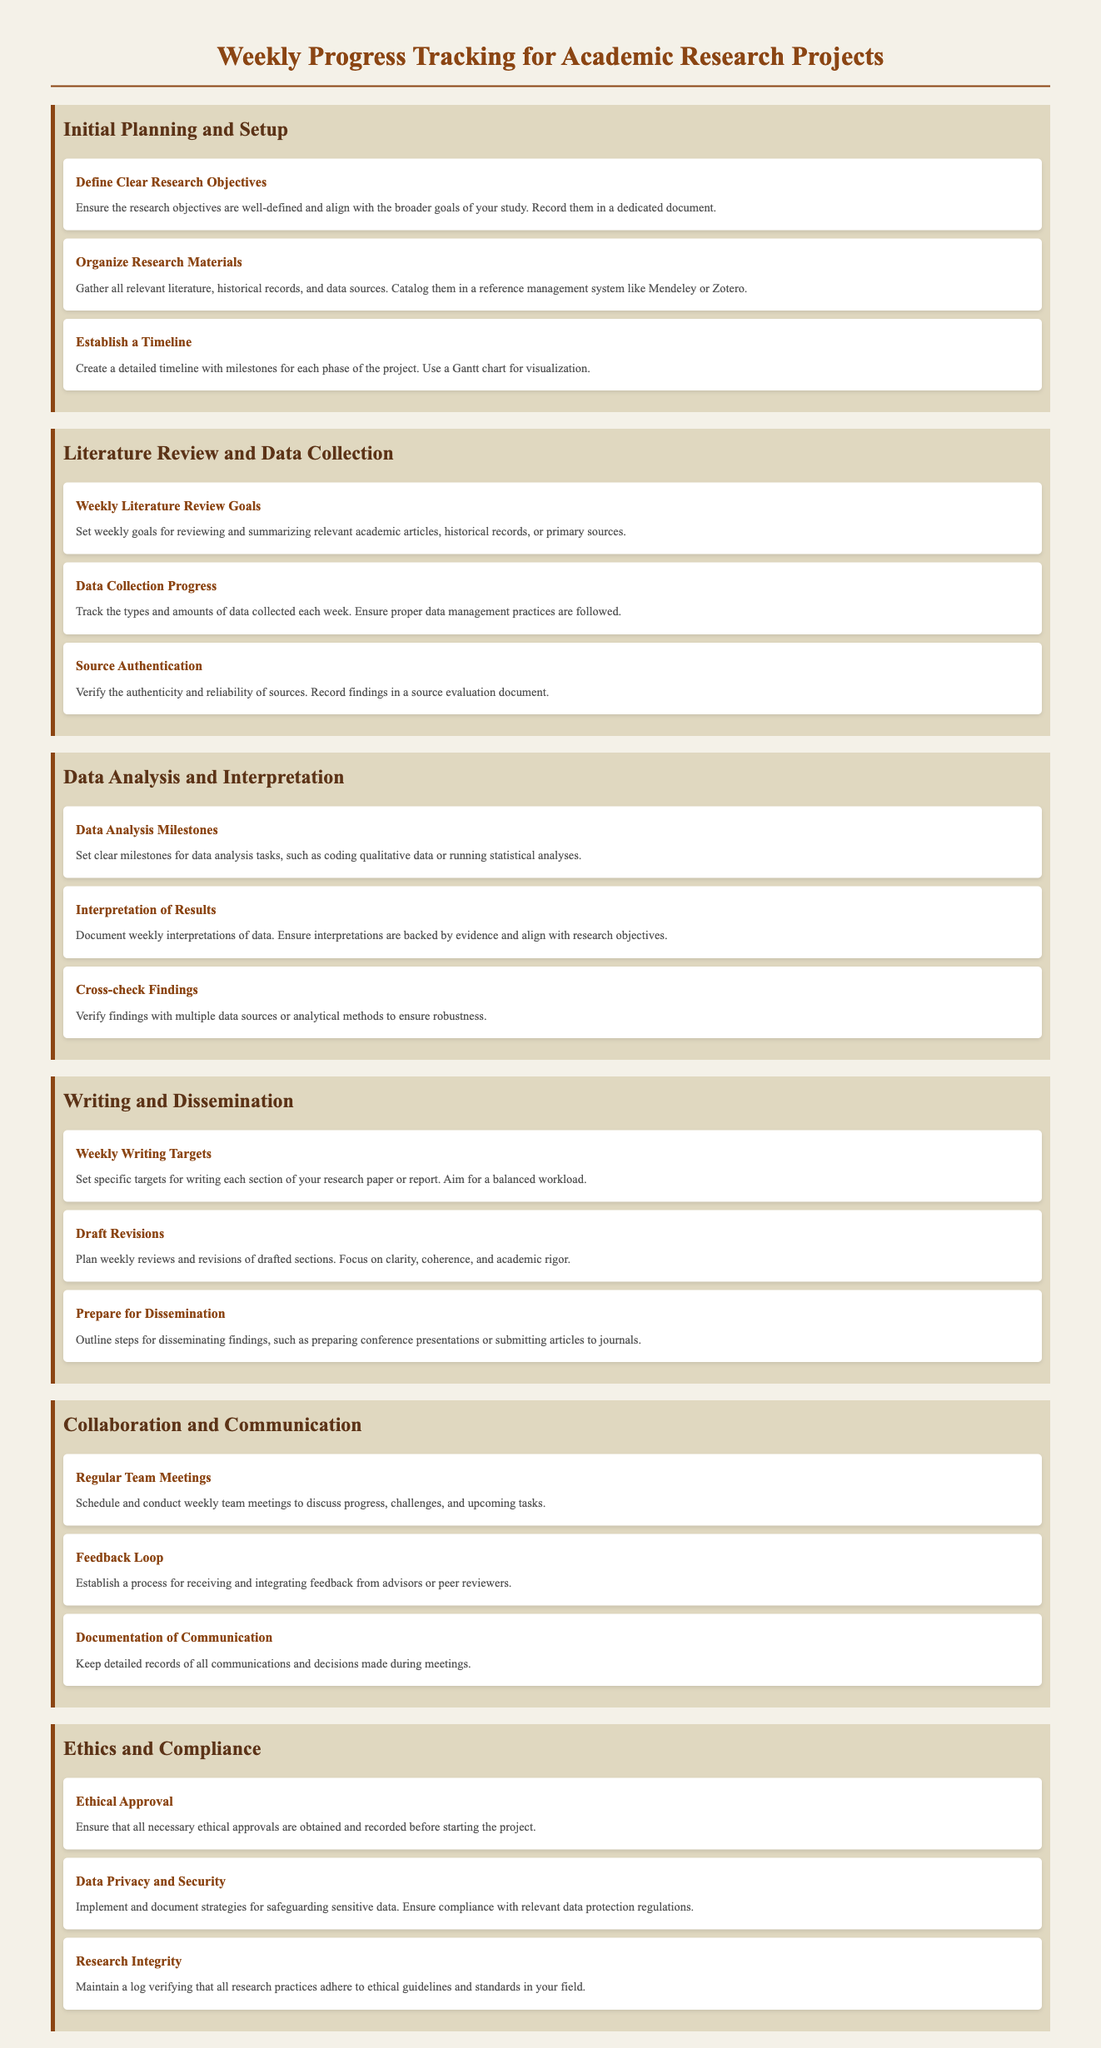what is the title of the document? The title of the document is indicated at the top of the rendered content as the main heading.
Answer: Weekly Progress Tracking for Academic Research Projects how many categories are listed in the checklist? The number of categories can be determined by counting the sections present in the document.
Answer: Six what item is listed under "Initial Planning and Setup" that involves collecting literature? This item specifies an action related to the collection and organization of research materials.
Answer: Organize Research Materials what is a weekly goal mentioned in the "Literature Review and Data Collection" category? The weekly goal pertains to reviewing and summarizing academic articles.
Answer: Weekly Literature Review Goals what milestone is set for data analysis tasks? This milestone defines a key task in the data analysis phase.
Answer: Data Analysis Milestones which category includes the item "Weekly Writing Targets"? The question focuses on identifying the section where this specific writing-related target is categorized.
Answer: Writing and Dissemination what is required to ensure ethical compliance before starting the project? This requirement relates to obtaining a necessary approval mentioned in the ethics section.
Answer: Ethical Approval which item discusses the importance of team meetings? This item emphasizes regular communication among team members during the project.
Answer: Regular Team Meetings what is the purpose of documenting communication in the "Collaboration and Communication" category? The purpose relates to recording discussions and decisions made during project meetings.
Answer: Documentation of Communication 